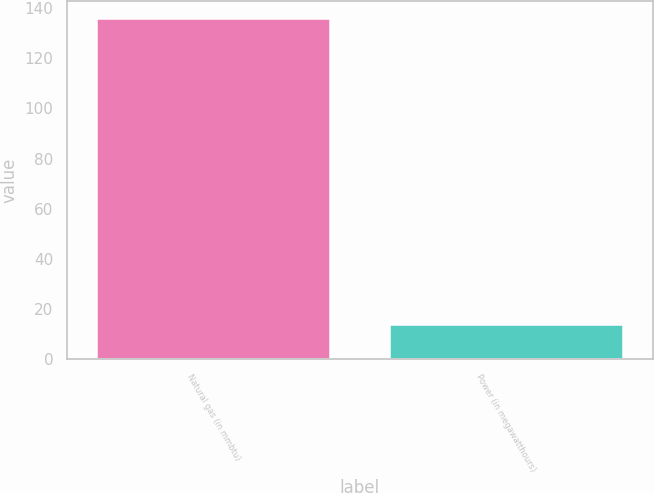<chart> <loc_0><loc_0><loc_500><loc_500><bar_chart><fcel>Natural gas (in mmbtu)<fcel>Power (in megawatthours)<nl><fcel>136<fcel>14<nl></chart> 